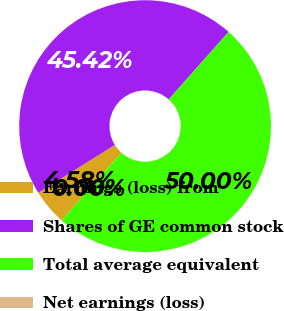Convert chart to OTSL. <chart><loc_0><loc_0><loc_500><loc_500><pie_chart><fcel>Earnings (loss) from<fcel>Shares of GE common stock<fcel>Total average equivalent<fcel>Net earnings (loss)<nl><fcel>4.58%<fcel>45.42%<fcel>50.0%<fcel>0.0%<nl></chart> 